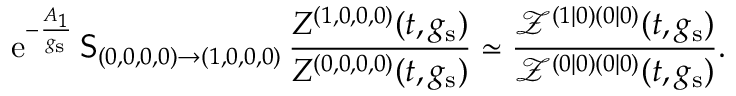Convert formula to latex. <formula><loc_0><loc_0><loc_500><loc_500>{ e } ^ { - \frac { A _ { 1 } } { g _ { s } } } \, S _ { ( 0 , 0 , 0 , 0 ) \to ( 1 , 0 , 0 , 0 ) } \, \frac { Z ^ { ( 1 , 0 , 0 , 0 ) } ( t , g _ { s } ) } { Z ^ { ( 0 , 0 , 0 , 0 ) } ( t , g _ { s } ) } \simeq \frac { \mathcal { Z } ^ { ( 1 | 0 ) ( 0 | 0 ) } ( t , g _ { s } ) } { \mathcal { Z } ^ { ( 0 | 0 ) ( 0 | 0 ) } ( t , g _ { s } ) } .</formula> 